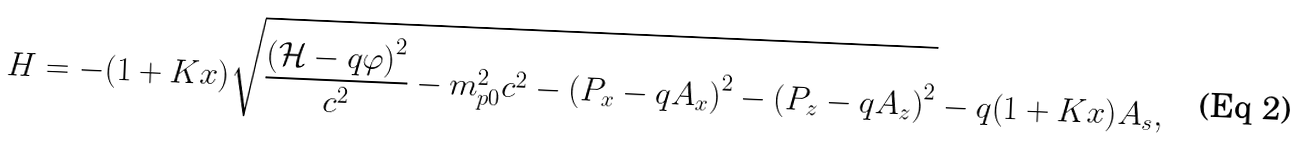<formula> <loc_0><loc_0><loc_500><loc_500>H = - { \left ( 1 + K x \right ) } { \sqrt { { \frac { { \left ( { \mathcal { H } } - q \varphi \right ) } ^ { 2 } } { c ^ { 2 } } } - m _ { p 0 } ^ { 2 } c ^ { 2 } - { \left ( P _ { x } - q A _ { x } \right ) } ^ { 2 } - { \left ( P _ { z } - q A _ { z } \right ) } ^ { 2 } } } - q { \left ( 1 + K x \right ) } A _ { s } ,</formula> 